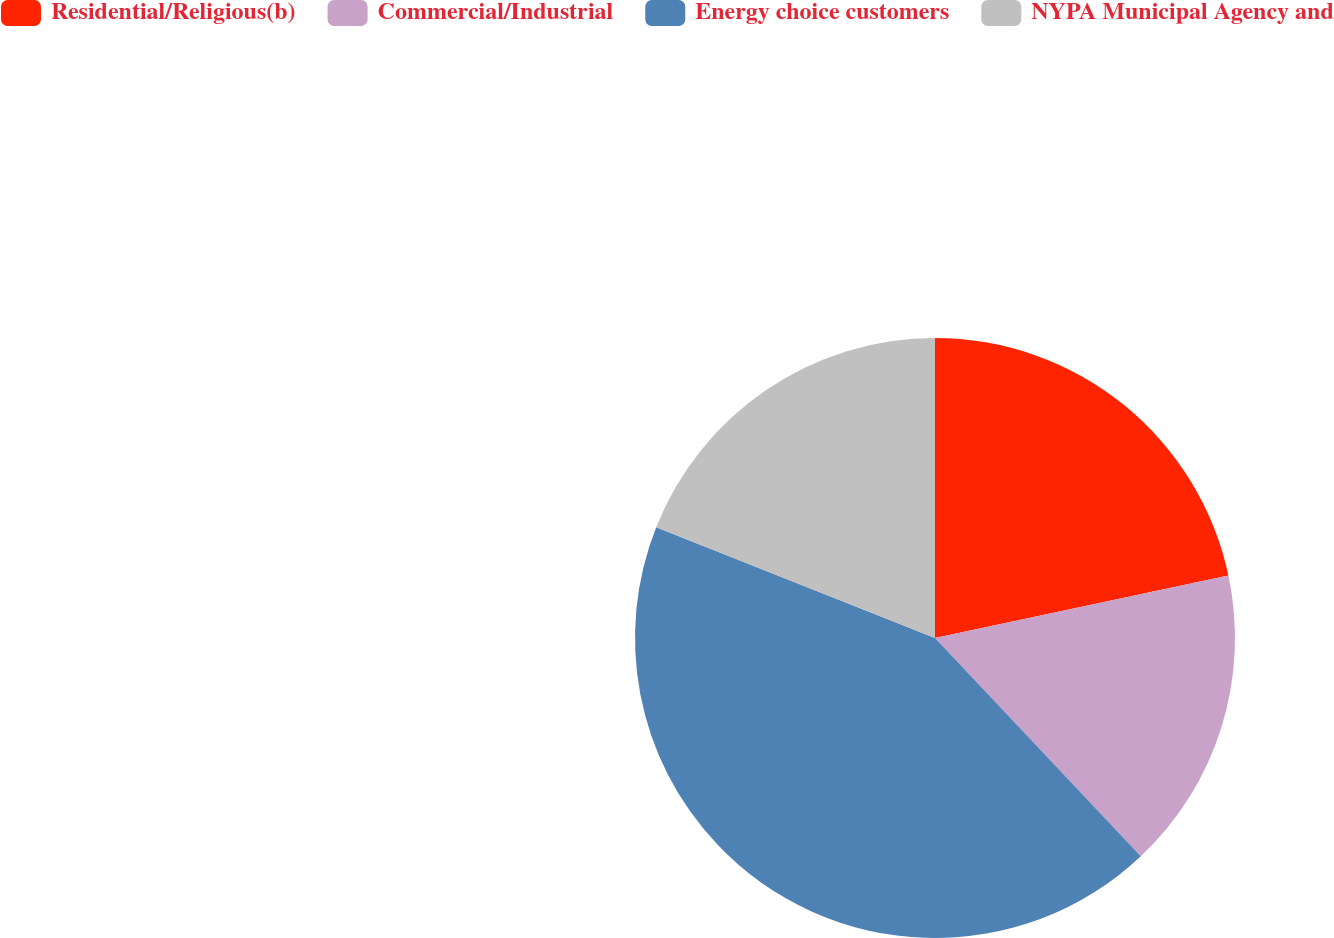Convert chart to OTSL. <chart><loc_0><loc_0><loc_500><loc_500><pie_chart><fcel>Residential/Religious(b)<fcel>Commercial/Industrial<fcel>Energy choice customers<fcel>NYPA Municipal Agency and<nl><fcel>21.66%<fcel>16.31%<fcel>43.05%<fcel>18.98%<nl></chart> 